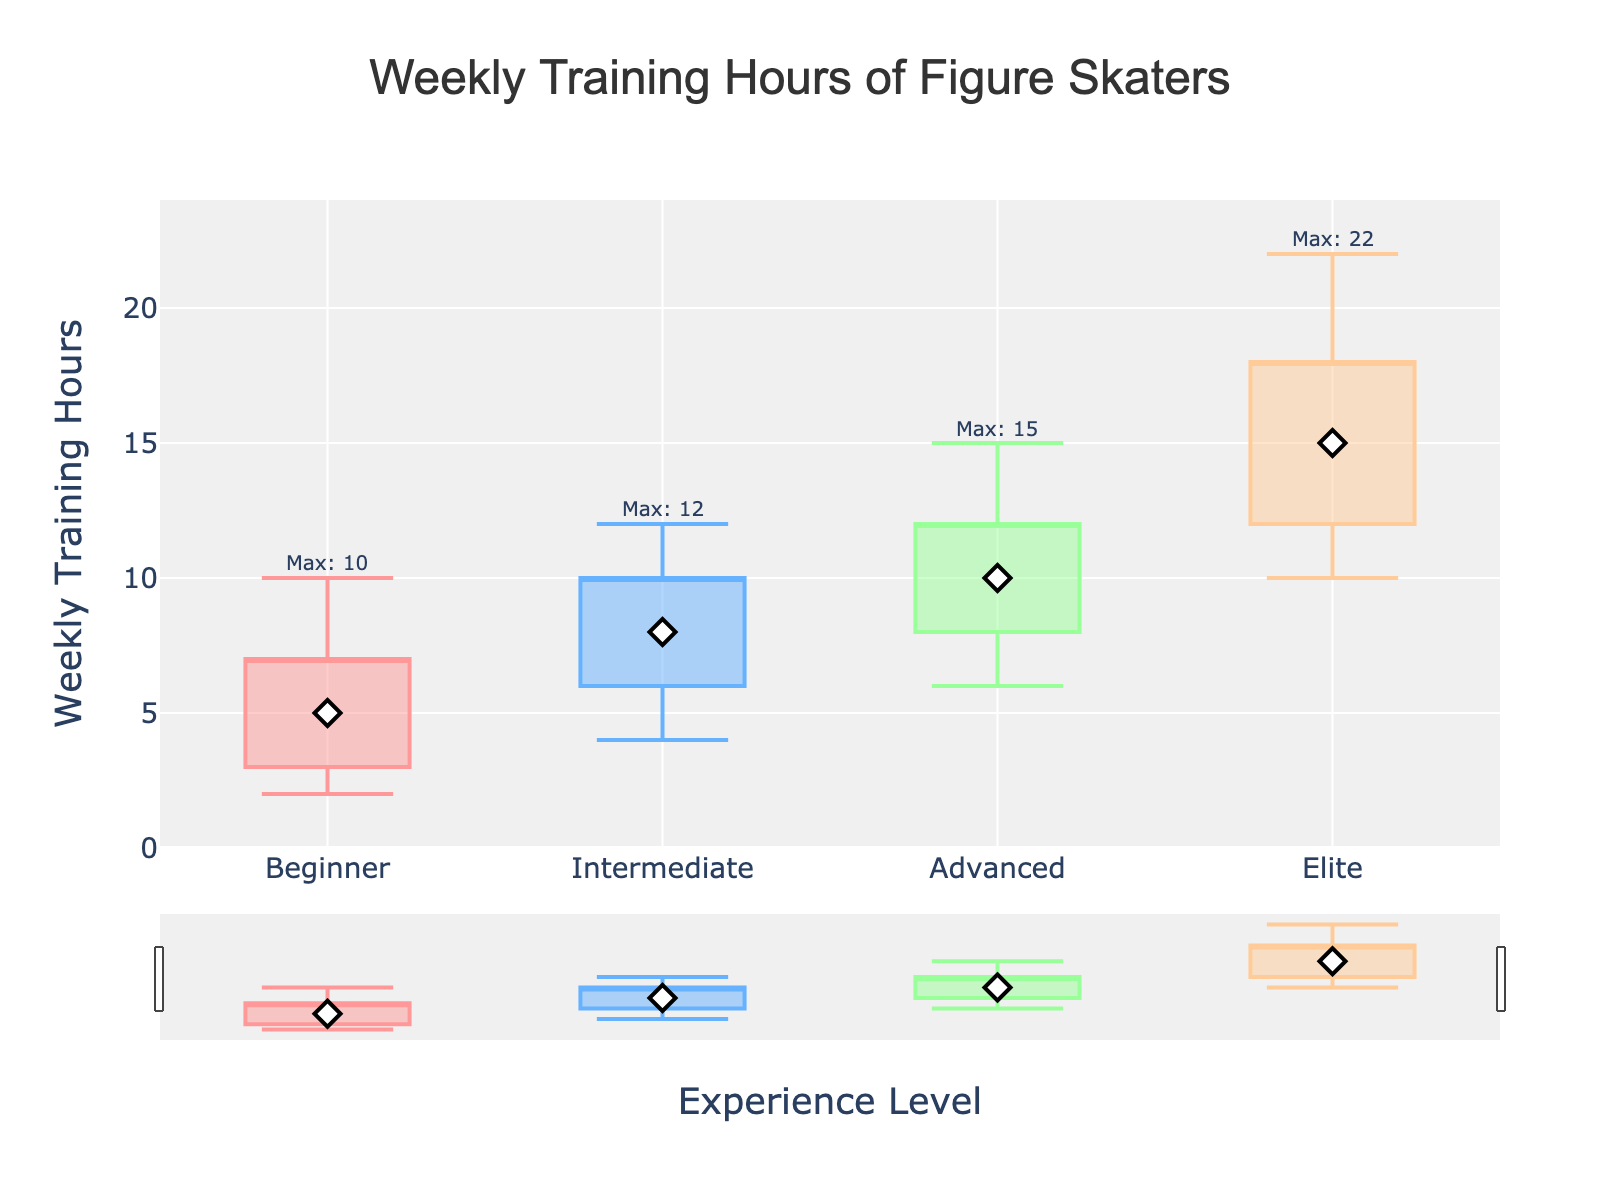Which experience level has the highest median weekly training hours? The "Elite" level's median is represented by the white diamond at 15 hours.
Answer: Elite What is the minimum weekly training hours for Intermediate skaters? The minimum is at the bottom of the candlestick for Intermediate skaters, which is 4 hours.
Answer: 4 Which group shows the widest range between the minimum and maximum weekly training hours? The range for each group: Beginner (2 to 10) is 8 hours, Intermediate (4 to 12) is 8 hours, Advanced (6 to 15) is 9 hours, Elite (10 to 22) is 12 hours. The widest range is for Elite.
Answer: Elite How do the 75th percentile values compare between Beginner and Elite skaters? The top of the box part of the candlestick for Beginner is 7, and for Elite is 18 hours. Elite is higher.
Answer: Elite By how much do the minimum training hours of Advanced skaters exceed the 25th percentile of Beginner skaters? The minimum for Advanced is 6 and the 25th percentile for Beginner is 3. The difference is 6 - 3 = 3 hours.
Answer: 3 What is the average of the medians for all experience levels? The medians are summed up: 5 (Beginner) + 8 (Intermediate) + 10 (Advanced) + 15 (Elite) = 38. The average is 38 / 4 = 9.5 hours.
Answer: 9.5 Which experience level displays the lowest maximum weekly training hours? The top of the candlestick (whisker) indicates the maximum. For Beginner, it's 10 hours, which is the lowest among all groups.
Answer: Beginner 